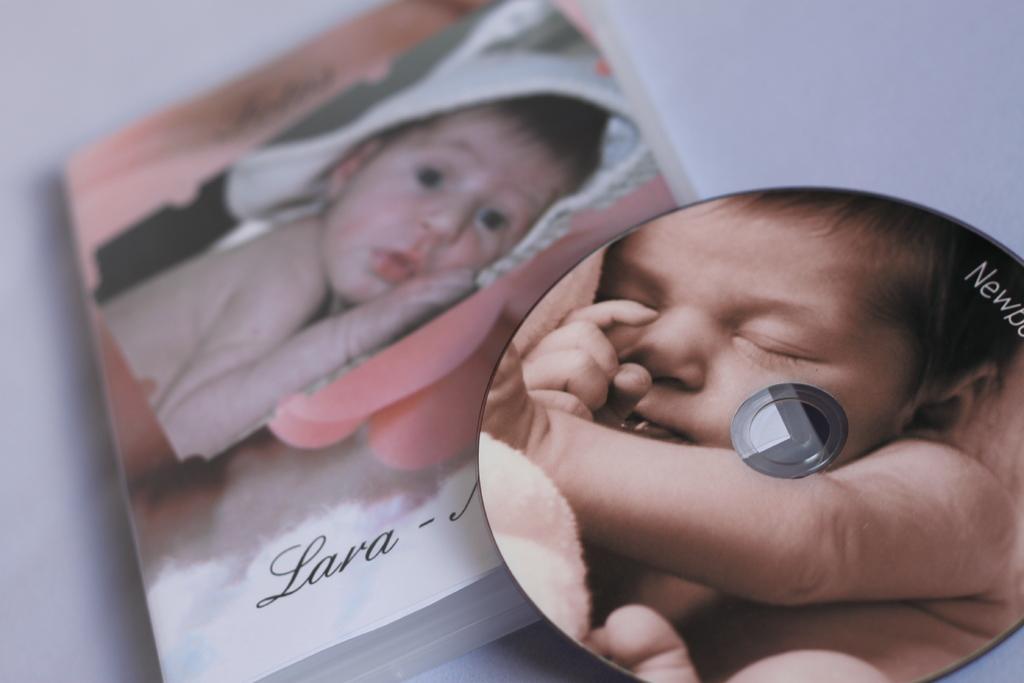In one or two sentences, can you explain what this image depicts? In this image I can see there is a baby photo on the cassette. On the left side there is another baby photo on the book. 